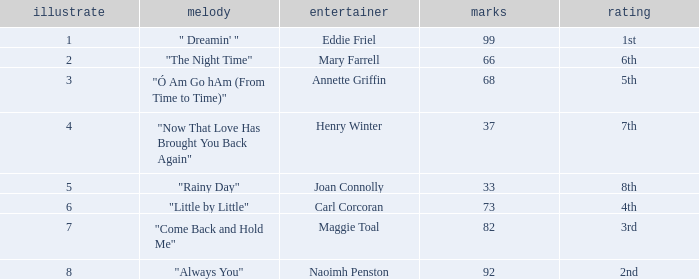Parse the full table. {'header': ['illustrate', 'melody', 'entertainer', 'marks', 'rating'], 'rows': [['1', '" Dreamin\' "', 'Eddie Friel', '99', '1st'], ['2', '"The Night Time"', 'Mary Farrell', '66', '6th'], ['3', '"Ó Am Go hAm (From Time to Time)"', 'Annette Griffin', '68', '5th'], ['4', '"Now That Love Has Brought You Back Again"', 'Henry Winter', '37', '7th'], ['5', '"Rainy Day"', 'Joan Connolly', '33', '8th'], ['6', '"Little by Little"', 'Carl Corcoran', '73', '4th'], ['7', '"Come Back and Hold Me"', 'Maggie Toal', '82', '3rd'], ['8', '"Always You"', 'Naoimh Penston', '92', '2nd']]} What is the average number of points when the ranking is 7th and the draw is less than 4? None. 